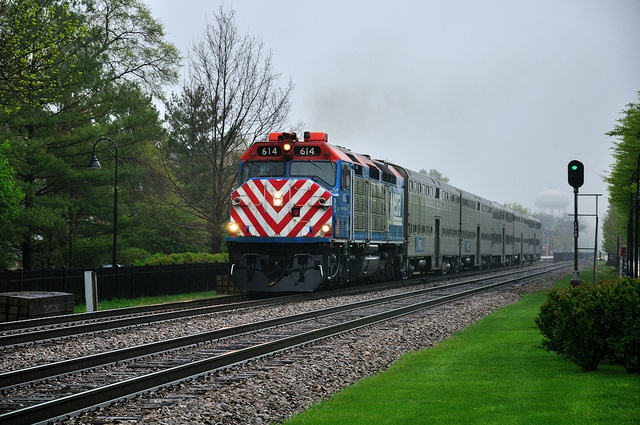Describe the objects in this image and their specific colors. I can see train in lightgray, black, gray, darkgray, and brown tones and traffic light in lightgray, black, gray, darkgreen, and green tones in this image. 